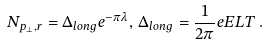Convert formula to latex. <formula><loc_0><loc_0><loc_500><loc_500>N _ { { p _ { \perp } } , r } = \Delta _ { l o n g } e ^ { - \pi \lambda } , \, \Delta _ { l o n g } = \frac { 1 } { 2 \pi } e E L T \, .</formula> 